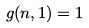Convert formula to latex. <formula><loc_0><loc_0><loc_500><loc_500>g ( n , 1 ) = 1</formula> 